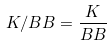Convert formula to latex. <formula><loc_0><loc_0><loc_500><loc_500>K / B B = \frac { K } { B B }</formula> 